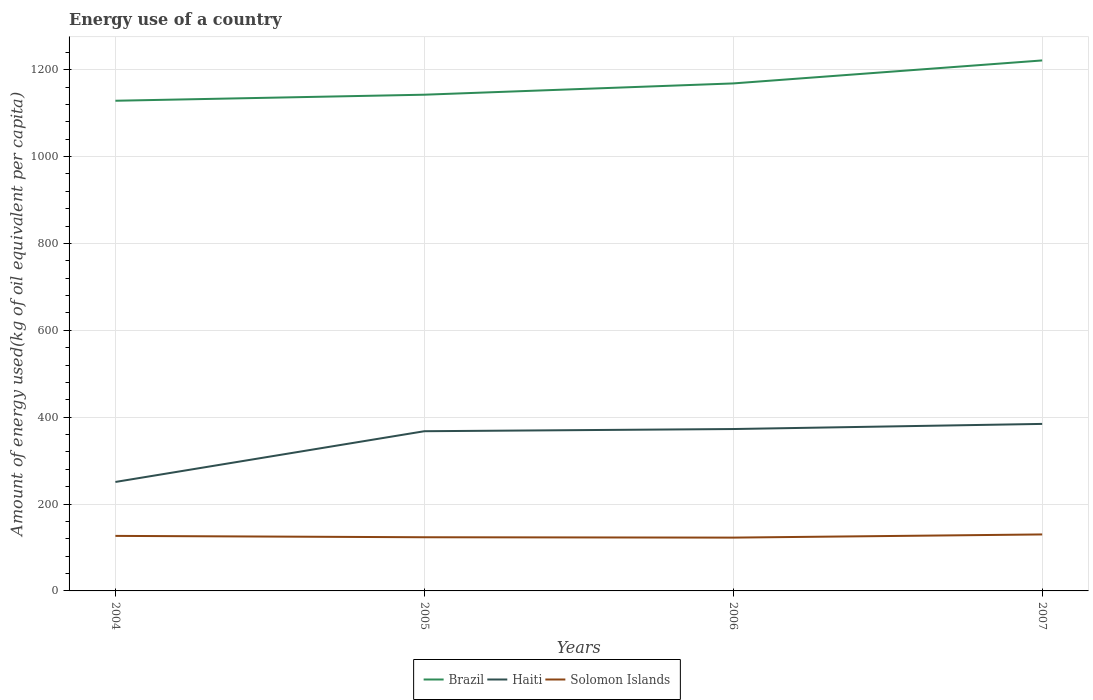How many different coloured lines are there?
Provide a succinct answer. 3. Does the line corresponding to Solomon Islands intersect with the line corresponding to Brazil?
Give a very brief answer. No. Is the number of lines equal to the number of legend labels?
Make the answer very short. Yes. Across all years, what is the maximum amount of energy used in in Haiti?
Give a very brief answer. 250.87. In which year was the amount of energy used in in Solomon Islands maximum?
Your answer should be very brief. 2006. What is the total amount of energy used in in Brazil in the graph?
Offer a terse response. -52.93. What is the difference between the highest and the second highest amount of energy used in in Haiti?
Your answer should be very brief. 133.64. What is the difference between the highest and the lowest amount of energy used in in Brazil?
Provide a short and direct response. 2. How many years are there in the graph?
Offer a very short reply. 4. What is the difference between two consecutive major ticks on the Y-axis?
Provide a short and direct response. 200. Does the graph contain any zero values?
Your response must be concise. No. Does the graph contain grids?
Give a very brief answer. Yes. How are the legend labels stacked?
Provide a succinct answer. Horizontal. What is the title of the graph?
Your answer should be compact. Energy use of a country. Does "St. Lucia" appear as one of the legend labels in the graph?
Keep it short and to the point. No. What is the label or title of the Y-axis?
Your answer should be very brief. Amount of energy used(kg of oil equivalent per capita). What is the Amount of energy used(kg of oil equivalent per capita) in Brazil in 2004?
Keep it short and to the point. 1128.55. What is the Amount of energy used(kg of oil equivalent per capita) of Haiti in 2004?
Your answer should be compact. 250.87. What is the Amount of energy used(kg of oil equivalent per capita) in Solomon Islands in 2004?
Make the answer very short. 126.68. What is the Amount of energy used(kg of oil equivalent per capita) of Brazil in 2005?
Your response must be concise. 1142.47. What is the Amount of energy used(kg of oil equivalent per capita) of Haiti in 2005?
Keep it short and to the point. 367.7. What is the Amount of energy used(kg of oil equivalent per capita) in Solomon Islands in 2005?
Offer a very short reply. 123.59. What is the Amount of energy used(kg of oil equivalent per capita) of Brazil in 2006?
Keep it short and to the point. 1168.43. What is the Amount of energy used(kg of oil equivalent per capita) of Haiti in 2006?
Keep it short and to the point. 372.73. What is the Amount of energy used(kg of oil equivalent per capita) of Solomon Islands in 2006?
Give a very brief answer. 122.73. What is the Amount of energy used(kg of oil equivalent per capita) in Brazil in 2007?
Provide a succinct answer. 1221.36. What is the Amount of energy used(kg of oil equivalent per capita) in Haiti in 2007?
Offer a terse response. 384.51. What is the Amount of energy used(kg of oil equivalent per capita) in Solomon Islands in 2007?
Provide a succinct answer. 130.06. Across all years, what is the maximum Amount of energy used(kg of oil equivalent per capita) in Brazil?
Keep it short and to the point. 1221.36. Across all years, what is the maximum Amount of energy used(kg of oil equivalent per capita) in Haiti?
Your answer should be very brief. 384.51. Across all years, what is the maximum Amount of energy used(kg of oil equivalent per capita) in Solomon Islands?
Offer a very short reply. 130.06. Across all years, what is the minimum Amount of energy used(kg of oil equivalent per capita) of Brazil?
Your response must be concise. 1128.55. Across all years, what is the minimum Amount of energy used(kg of oil equivalent per capita) in Haiti?
Your answer should be very brief. 250.87. Across all years, what is the minimum Amount of energy used(kg of oil equivalent per capita) in Solomon Islands?
Make the answer very short. 122.73. What is the total Amount of energy used(kg of oil equivalent per capita) in Brazil in the graph?
Give a very brief answer. 4660.82. What is the total Amount of energy used(kg of oil equivalent per capita) in Haiti in the graph?
Give a very brief answer. 1375.81. What is the total Amount of energy used(kg of oil equivalent per capita) in Solomon Islands in the graph?
Your answer should be compact. 503.06. What is the difference between the Amount of energy used(kg of oil equivalent per capita) in Brazil in 2004 and that in 2005?
Offer a very short reply. -13.92. What is the difference between the Amount of energy used(kg of oil equivalent per capita) of Haiti in 2004 and that in 2005?
Your response must be concise. -116.83. What is the difference between the Amount of energy used(kg of oil equivalent per capita) in Solomon Islands in 2004 and that in 2005?
Keep it short and to the point. 3.09. What is the difference between the Amount of energy used(kg of oil equivalent per capita) in Brazil in 2004 and that in 2006?
Keep it short and to the point. -39.88. What is the difference between the Amount of energy used(kg of oil equivalent per capita) in Haiti in 2004 and that in 2006?
Ensure brevity in your answer.  -121.85. What is the difference between the Amount of energy used(kg of oil equivalent per capita) of Solomon Islands in 2004 and that in 2006?
Keep it short and to the point. 3.95. What is the difference between the Amount of energy used(kg of oil equivalent per capita) in Brazil in 2004 and that in 2007?
Ensure brevity in your answer.  -92.81. What is the difference between the Amount of energy used(kg of oil equivalent per capita) of Haiti in 2004 and that in 2007?
Provide a succinct answer. -133.64. What is the difference between the Amount of energy used(kg of oil equivalent per capita) in Solomon Islands in 2004 and that in 2007?
Provide a short and direct response. -3.38. What is the difference between the Amount of energy used(kg of oil equivalent per capita) of Brazil in 2005 and that in 2006?
Offer a very short reply. -25.96. What is the difference between the Amount of energy used(kg of oil equivalent per capita) in Haiti in 2005 and that in 2006?
Make the answer very short. -5.03. What is the difference between the Amount of energy used(kg of oil equivalent per capita) of Solomon Islands in 2005 and that in 2006?
Keep it short and to the point. 0.85. What is the difference between the Amount of energy used(kg of oil equivalent per capita) of Brazil in 2005 and that in 2007?
Offer a terse response. -78.89. What is the difference between the Amount of energy used(kg of oil equivalent per capita) in Haiti in 2005 and that in 2007?
Ensure brevity in your answer.  -16.82. What is the difference between the Amount of energy used(kg of oil equivalent per capita) in Solomon Islands in 2005 and that in 2007?
Your answer should be compact. -6.47. What is the difference between the Amount of energy used(kg of oil equivalent per capita) in Brazil in 2006 and that in 2007?
Provide a succinct answer. -52.93. What is the difference between the Amount of energy used(kg of oil equivalent per capita) of Haiti in 2006 and that in 2007?
Ensure brevity in your answer.  -11.79. What is the difference between the Amount of energy used(kg of oil equivalent per capita) of Solomon Islands in 2006 and that in 2007?
Keep it short and to the point. -7.33. What is the difference between the Amount of energy used(kg of oil equivalent per capita) in Brazil in 2004 and the Amount of energy used(kg of oil equivalent per capita) in Haiti in 2005?
Offer a terse response. 760.86. What is the difference between the Amount of energy used(kg of oil equivalent per capita) in Brazil in 2004 and the Amount of energy used(kg of oil equivalent per capita) in Solomon Islands in 2005?
Provide a short and direct response. 1004.97. What is the difference between the Amount of energy used(kg of oil equivalent per capita) of Haiti in 2004 and the Amount of energy used(kg of oil equivalent per capita) of Solomon Islands in 2005?
Keep it short and to the point. 127.28. What is the difference between the Amount of energy used(kg of oil equivalent per capita) in Brazil in 2004 and the Amount of energy used(kg of oil equivalent per capita) in Haiti in 2006?
Your answer should be compact. 755.83. What is the difference between the Amount of energy used(kg of oil equivalent per capita) in Brazil in 2004 and the Amount of energy used(kg of oil equivalent per capita) in Solomon Islands in 2006?
Give a very brief answer. 1005.82. What is the difference between the Amount of energy used(kg of oil equivalent per capita) in Haiti in 2004 and the Amount of energy used(kg of oil equivalent per capita) in Solomon Islands in 2006?
Keep it short and to the point. 128.14. What is the difference between the Amount of energy used(kg of oil equivalent per capita) of Brazil in 2004 and the Amount of energy used(kg of oil equivalent per capita) of Haiti in 2007?
Provide a succinct answer. 744.04. What is the difference between the Amount of energy used(kg of oil equivalent per capita) of Brazil in 2004 and the Amount of energy used(kg of oil equivalent per capita) of Solomon Islands in 2007?
Keep it short and to the point. 998.49. What is the difference between the Amount of energy used(kg of oil equivalent per capita) in Haiti in 2004 and the Amount of energy used(kg of oil equivalent per capita) in Solomon Islands in 2007?
Offer a terse response. 120.81. What is the difference between the Amount of energy used(kg of oil equivalent per capita) in Brazil in 2005 and the Amount of energy used(kg of oil equivalent per capita) in Haiti in 2006?
Offer a very short reply. 769.75. What is the difference between the Amount of energy used(kg of oil equivalent per capita) in Brazil in 2005 and the Amount of energy used(kg of oil equivalent per capita) in Solomon Islands in 2006?
Make the answer very short. 1019.74. What is the difference between the Amount of energy used(kg of oil equivalent per capita) in Haiti in 2005 and the Amount of energy used(kg of oil equivalent per capita) in Solomon Islands in 2006?
Provide a short and direct response. 244.96. What is the difference between the Amount of energy used(kg of oil equivalent per capita) in Brazil in 2005 and the Amount of energy used(kg of oil equivalent per capita) in Haiti in 2007?
Keep it short and to the point. 757.96. What is the difference between the Amount of energy used(kg of oil equivalent per capita) of Brazil in 2005 and the Amount of energy used(kg of oil equivalent per capita) of Solomon Islands in 2007?
Your answer should be compact. 1012.41. What is the difference between the Amount of energy used(kg of oil equivalent per capita) in Haiti in 2005 and the Amount of energy used(kg of oil equivalent per capita) in Solomon Islands in 2007?
Your answer should be very brief. 237.64. What is the difference between the Amount of energy used(kg of oil equivalent per capita) of Brazil in 2006 and the Amount of energy used(kg of oil equivalent per capita) of Haiti in 2007?
Your answer should be very brief. 783.92. What is the difference between the Amount of energy used(kg of oil equivalent per capita) in Brazil in 2006 and the Amount of energy used(kg of oil equivalent per capita) in Solomon Islands in 2007?
Give a very brief answer. 1038.37. What is the difference between the Amount of energy used(kg of oil equivalent per capita) in Haiti in 2006 and the Amount of energy used(kg of oil equivalent per capita) in Solomon Islands in 2007?
Make the answer very short. 242.66. What is the average Amount of energy used(kg of oil equivalent per capita) of Brazil per year?
Provide a short and direct response. 1165.2. What is the average Amount of energy used(kg of oil equivalent per capita) in Haiti per year?
Offer a very short reply. 343.95. What is the average Amount of energy used(kg of oil equivalent per capita) of Solomon Islands per year?
Give a very brief answer. 125.77. In the year 2004, what is the difference between the Amount of energy used(kg of oil equivalent per capita) of Brazil and Amount of energy used(kg of oil equivalent per capita) of Haiti?
Your answer should be very brief. 877.68. In the year 2004, what is the difference between the Amount of energy used(kg of oil equivalent per capita) in Brazil and Amount of energy used(kg of oil equivalent per capita) in Solomon Islands?
Give a very brief answer. 1001.87. In the year 2004, what is the difference between the Amount of energy used(kg of oil equivalent per capita) of Haiti and Amount of energy used(kg of oil equivalent per capita) of Solomon Islands?
Provide a succinct answer. 124.19. In the year 2005, what is the difference between the Amount of energy used(kg of oil equivalent per capita) of Brazil and Amount of energy used(kg of oil equivalent per capita) of Haiti?
Your response must be concise. 774.77. In the year 2005, what is the difference between the Amount of energy used(kg of oil equivalent per capita) in Brazil and Amount of energy used(kg of oil equivalent per capita) in Solomon Islands?
Ensure brevity in your answer.  1018.88. In the year 2005, what is the difference between the Amount of energy used(kg of oil equivalent per capita) of Haiti and Amount of energy used(kg of oil equivalent per capita) of Solomon Islands?
Keep it short and to the point. 244.11. In the year 2006, what is the difference between the Amount of energy used(kg of oil equivalent per capita) in Brazil and Amount of energy used(kg of oil equivalent per capita) in Haiti?
Offer a terse response. 795.71. In the year 2006, what is the difference between the Amount of energy used(kg of oil equivalent per capita) of Brazil and Amount of energy used(kg of oil equivalent per capita) of Solomon Islands?
Offer a very short reply. 1045.7. In the year 2006, what is the difference between the Amount of energy used(kg of oil equivalent per capita) in Haiti and Amount of energy used(kg of oil equivalent per capita) in Solomon Islands?
Make the answer very short. 249.99. In the year 2007, what is the difference between the Amount of energy used(kg of oil equivalent per capita) in Brazil and Amount of energy used(kg of oil equivalent per capita) in Haiti?
Your response must be concise. 836.85. In the year 2007, what is the difference between the Amount of energy used(kg of oil equivalent per capita) of Brazil and Amount of energy used(kg of oil equivalent per capita) of Solomon Islands?
Give a very brief answer. 1091.3. In the year 2007, what is the difference between the Amount of energy used(kg of oil equivalent per capita) of Haiti and Amount of energy used(kg of oil equivalent per capita) of Solomon Islands?
Offer a very short reply. 254.45. What is the ratio of the Amount of energy used(kg of oil equivalent per capita) in Brazil in 2004 to that in 2005?
Give a very brief answer. 0.99. What is the ratio of the Amount of energy used(kg of oil equivalent per capita) of Haiti in 2004 to that in 2005?
Make the answer very short. 0.68. What is the ratio of the Amount of energy used(kg of oil equivalent per capita) of Solomon Islands in 2004 to that in 2005?
Offer a very short reply. 1.02. What is the ratio of the Amount of energy used(kg of oil equivalent per capita) of Brazil in 2004 to that in 2006?
Your answer should be compact. 0.97. What is the ratio of the Amount of energy used(kg of oil equivalent per capita) of Haiti in 2004 to that in 2006?
Offer a very short reply. 0.67. What is the ratio of the Amount of energy used(kg of oil equivalent per capita) of Solomon Islands in 2004 to that in 2006?
Offer a very short reply. 1.03. What is the ratio of the Amount of energy used(kg of oil equivalent per capita) in Brazil in 2004 to that in 2007?
Your answer should be compact. 0.92. What is the ratio of the Amount of energy used(kg of oil equivalent per capita) in Haiti in 2004 to that in 2007?
Make the answer very short. 0.65. What is the ratio of the Amount of energy used(kg of oil equivalent per capita) in Solomon Islands in 2004 to that in 2007?
Give a very brief answer. 0.97. What is the ratio of the Amount of energy used(kg of oil equivalent per capita) in Brazil in 2005 to that in 2006?
Make the answer very short. 0.98. What is the ratio of the Amount of energy used(kg of oil equivalent per capita) of Haiti in 2005 to that in 2006?
Offer a very short reply. 0.99. What is the ratio of the Amount of energy used(kg of oil equivalent per capita) in Solomon Islands in 2005 to that in 2006?
Provide a succinct answer. 1.01. What is the ratio of the Amount of energy used(kg of oil equivalent per capita) of Brazil in 2005 to that in 2007?
Provide a succinct answer. 0.94. What is the ratio of the Amount of energy used(kg of oil equivalent per capita) in Haiti in 2005 to that in 2007?
Your answer should be compact. 0.96. What is the ratio of the Amount of energy used(kg of oil equivalent per capita) of Solomon Islands in 2005 to that in 2007?
Keep it short and to the point. 0.95. What is the ratio of the Amount of energy used(kg of oil equivalent per capita) in Brazil in 2006 to that in 2007?
Your answer should be compact. 0.96. What is the ratio of the Amount of energy used(kg of oil equivalent per capita) of Haiti in 2006 to that in 2007?
Give a very brief answer. 0.97. What is the ratio of the Amount of energy used(kg of oil equivalent per capita) of Solomon Islands in 2006 to that in 2007?
Ensure brevity in your answer.  0.94. What is the difference between the highest and the second highest Amount of energy used(kg of oil equivalent per capita) in Brazil?
Offer a terse response. 52.93. What is the difference between the highest and the second highest Amount of energy used(kg of oil equivalent per capita) of Haiti?
Your response must be concise. 11.79. What is the difference between the highest and the second highest Amount of energy used(kg of oil equivalent per capita) of Solomon Islands?
Your response must be concise. 3.38. What is the difference between the highest and the lowest Amount of energy used(kg of oil equivalent per capita) in Brazil?
Keep it short and to the point. 92.81. What is the difference between the highest and the lowest Amount of energy used(kg of oil equivalent per capita) of Haiti?
Your response must be concise. 133.64. What is the difference between the highest and the lowest Amount of energy used(kg of oil equivalent per capita) in Solomon Islands?
Keep it short and to the point. 7.33. 